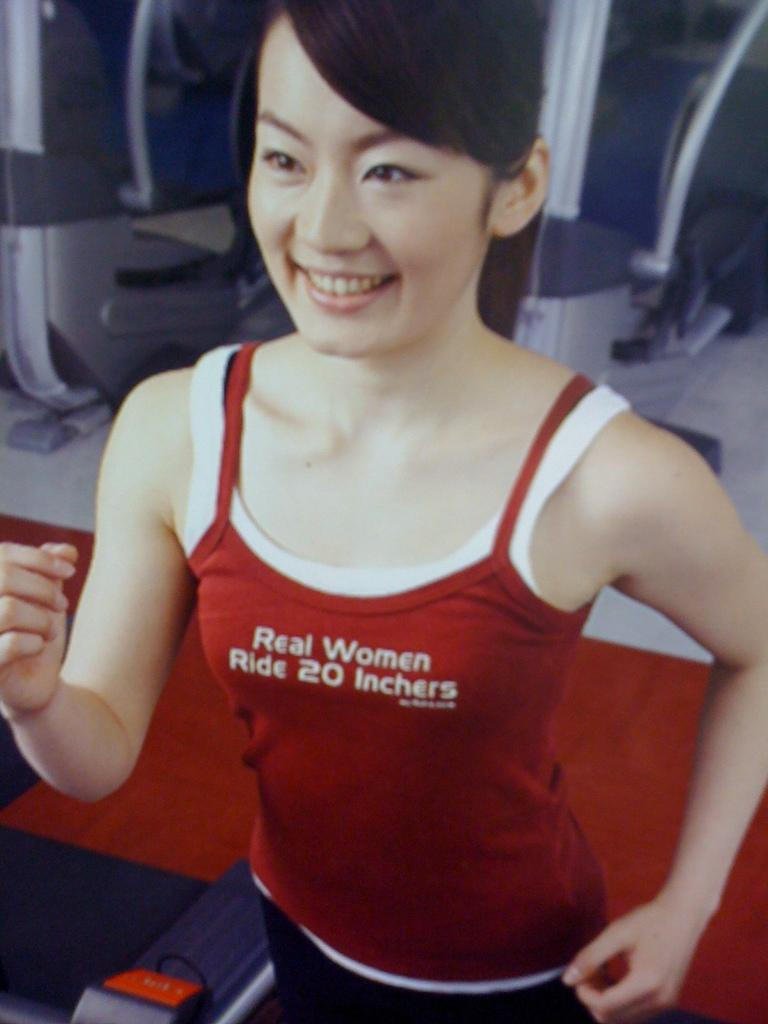<image>
Describe the image concisely. asian woman wearing red tanktop with words real women ride 20 inchers on it 